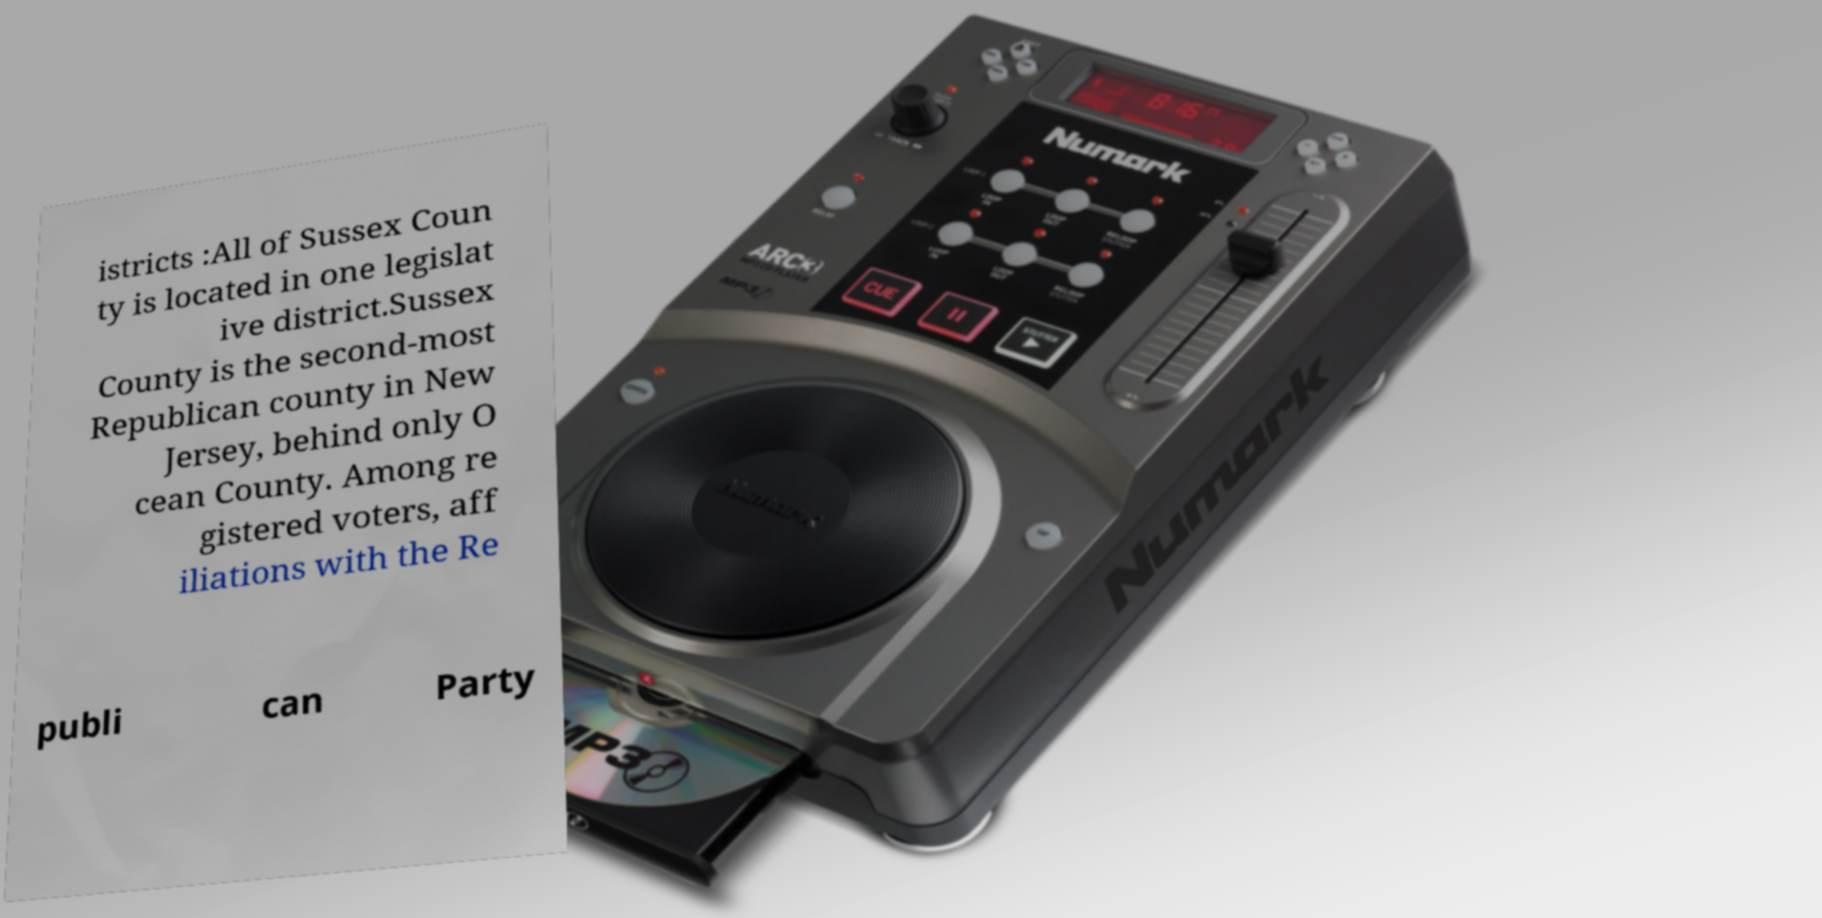Can you read and provide the text displayed in the image?This photo seems to have some interesting text. Can you extract and type it out for me? istricts :All of Sussex Coun ty is located in one legislat ive district.Sussex County is the second-most Republican county in New Jersey, behind only O cean County. Among re gistered voters, aff iliations with the Re publi can Party 